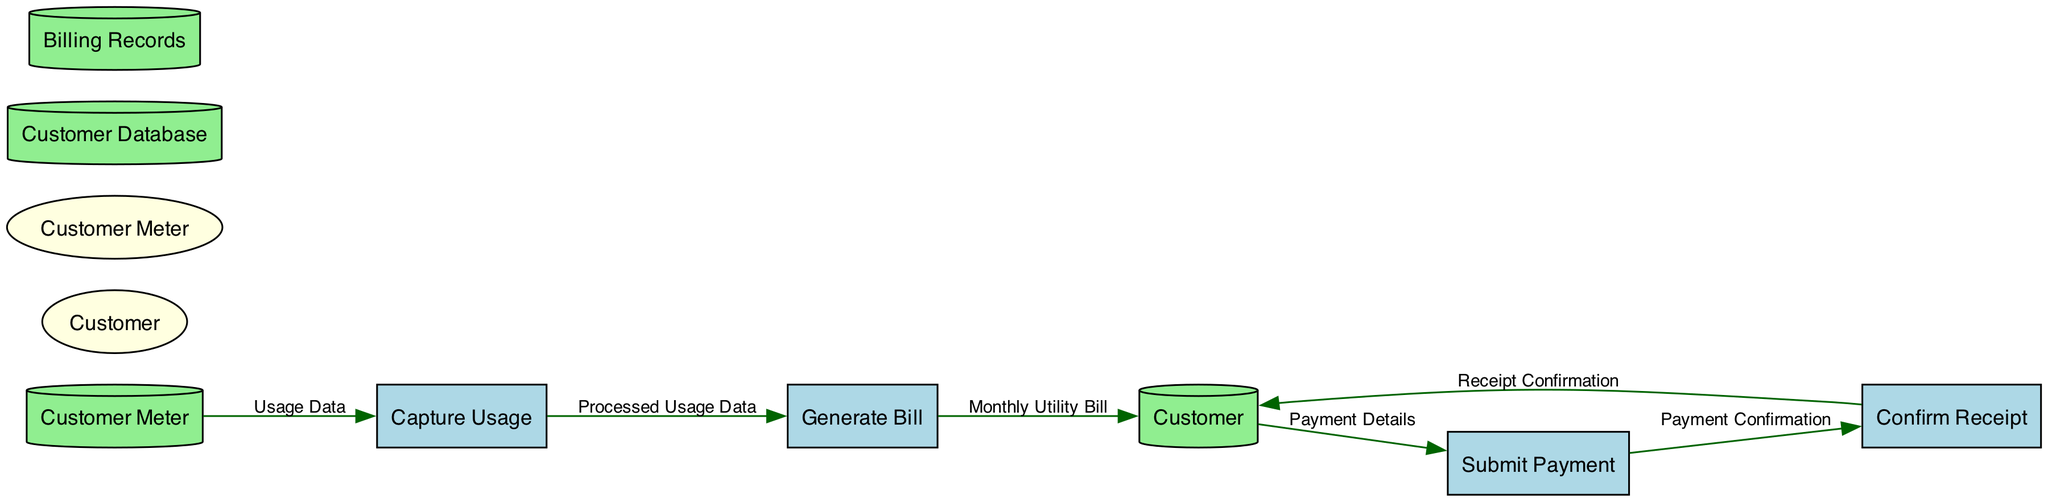What is the name of the first process? The first process listed in the diagram is "Capture Usage." This is explicitly mentioned in the processes section, which organizes processes based on their sequential order.
Answer: Capture Usage How many data stores are present in the diagram? The diagram includes two data stores: "Customer Database" and "Billing Records." This can be verified by counting the entries in the data stores section of the diagram.
Answer: 2 What data flows from "Capture Usage" to "Generate Bill"? The data flow from "Capture Usage" to "Generate Bill" is labeled "Processed Usage Data." This is directly stated in the data flows section describing the information exchanged between the two processes.
Answer: Processed Usage Data Which external entity is directly involved in submitting a payment? The external entity "Customer" is directly involved in submitting a payment as it connects to the "Submit Payment" process according to the flows defined in the diagram.
Answer: Customer What is the relationship between "Submit Payment" and "Confirm Receipt"? "Submit Payment" sends "Payment Confirmation" to "Confirm Receipt." This interaction is specified in the data flows section, indicating a direct connection and flow of information between these processes.
Answer: Payment Confirmation How many processes are there in total? There are four processes in the diagram: "Capture Usage," "Generate Bill," "Submit Payment," and "Confirm Receipt." Counting these processes directly from the sources confirms this number.
Answer: 4 What does the "Customer" receive after payment is confirmed? After payment is confirmed, the "Customer" receives "Receipt Confirmation" as indicated in the data flow between "Confirm Receipt" and "Customer."
Answer: Receipt Confirmation Which process generates the "Monthly Utility Bill"? The "Generate Bill" process is responsible for generating the "Monthly Utility Bill," as stated in the data flows where this process outputs this specific document to the Customer.
Answer: Generate Bill What does the "Customer Database" store? The "Customer Database" stores customer details and usage data according to the description provided within the data stores section of the diagram.
Answer: Customer details and usage data 